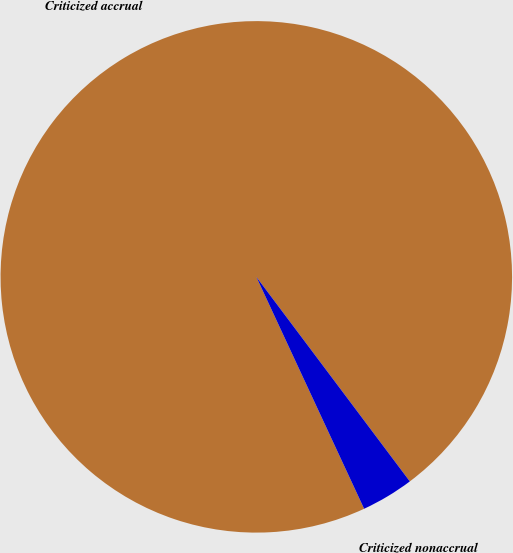<chart> <loc_0><loc_0><loc_500><loc_500><pie_chart><fcel>Criticized accrual<fcel>Criticized nonaccrual<nl><fcel>96.68%<fcel>3.32%<nl></chart> 